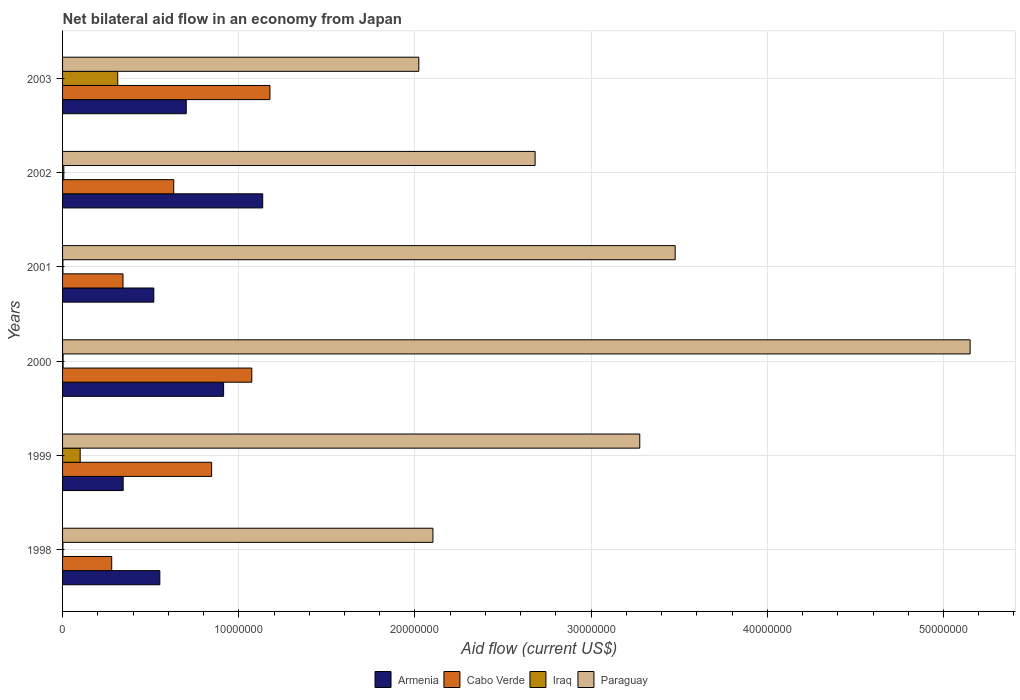How many groups of bars are there?
Offer a very short reply. 6. Are the number of bars on each tick of the Y-axis equal?
Keep it short and to the point. Yes. How many bars are there on the 5th tick from the bottom?
Provide a short and direct response. 4. What is the label of the 6th group of bars from the top?
Your answer should be compact. 1998. What is the net bilateral aid flow in Cabo Verde in 2001?
Your response must be concise. 3.43e+06. Across all years, what is the maximum net bilateral aid flow in Iraq?
Your answer should be compact. 3.13e+06. Across all years, what is the minimum net bilateral aid flow in Armenia?
Give a very brief answer. 3.44e+06. In which year was the net bilateral aid flow in Paraguay maximum?
Offer a very short reply. 2000. In which year was the net bilateral aid flow in Armenia minimum?
Your response must be concise. 1999. What is the total net bilateral aid flow in Paraguay in the graph?
Your answer should be very brief. 1.87e+08. What is the difference between the net bilateral aid flow in Armenia in 1999 and that in 2000?
Ensure brevity in your answer.  -5.70e+06. What is the difference between the net bilateral aid flow in Armenia in 2000 and the net bilateral aid flow in Cabo Verde in 2001?
Ensure brevity in your answer.  5.71e+06. What is the average net bilateral aid flow in Armenia per year?
Keep it short and to the point. 6.94e+06. In the year 2002, what is the difference between the net bilateral aid flow in Paraguay and net bilateral aid flow in Cabo Verde?
Your response must be concise. 2.05e+07. What is the ratio of the net bilateral aid flow in Armenia in 1998 to that in 2001?
Provide a succinct answer. 1.07. Is the net bilateral aid flow in Paraguay in 1998 less than that in 2001?
Keep it short and to the point. Yes. Is the difference between the net bilateral aid flow in Paraguay in 2001 and 2002 greater than the difference between the net bilateral aid flow in Cabo Verde in 2001 and 2002?
Your response must be concise. Yes. What is the difference between the highest and the second highest net bilateral aid flow in Cabo Verde?
Offer a terse response. 1.03e+06. What is the difference between the highest and the lowest net bilateral aid flow in Armenia?
Keep it short and to the point. 7.92e+06. In how many years, is the net bilateral aid flow in Cabo Verde greater than the average net bilateral aid flow in Cabo Verde taken over all years?
Provide a short and direct response. 3. What does the 3rd bar from the top in 1999 represents?
Your answer should be very brief. Cabo Verde. What does the 2nd bar from the bottom in 2000 represents?
Your response must be concise. Cabo Verde. How many years are there in the graph?
Make the answer very short. 6. What is the difference between two consecutive major ticks on the X-axis?
Your answer should be very brief. 1.00e+07. Does the graph contain any zero values?
Your answer should be compact. No. Where does the legend appear in the graph?
Provide a succinct answer. Bottom center. What is the title of the graph?
Provide a short and direct response. Net bilateral aid flow in an economy from Japan. Does "Turkmenistan" appear as one of the legend labels in the graph?
Offer a very short reply. No. What is the label or title of the X-axis?
Provide a short and direct response. Aid flow (current US$). What is the label or title of the Y-axis?
Your answer should be very brief. Years. What is the Aid flow (current US$) of Armenia in 1998?
Ensure brevity in your answer.  5.52e+06. What is the Aid flow (current US$) of Cabo Verde in 1998?
Keep it short and to the point. 2.79e+06. What is the Aid flow (current US$) of Iraq in 1998?
Your response must be concise. 2.00e+04. What is the Aid flow (current US$) in Paraguay in 1998?
Your response must be concise. 2.10e+07. What is the Aid flow (current US$) of Armenia in 1999?
Ensure brevity in your answer.  3.44e+06. What is the Aid flow (current US$) in Cabo Verde in 1999?
Make the answer very short. 8.46e+06. What is the Aid flow (current US$) in Paraguay in 1999?
Provide a short and direct response. 3.28e+07. What is the Aid flow (current US$) of Armenia in 2000?
Give a very brief answer. 9.14e+06. What is the Aid flow (current US$) in Cabo Verde in 2000?
Your answer should be very brief. 1.07e+07. What is the Aid flow (current US$) in Paraguay in 2000?
Provide a short and direct response. 5.15e+07. What is the Aid flow (current US$) in Armenia in 2001?
Provide a succinct answer. 5.18e+06. What is the Aid flow (current US$) of Cabo Verde in 2001?
Make the answer very short. 3.43e+06. What is the Aid flow (current US$) in Iraq in 2001?
Provide a short and direct response. 2.00e+04. What is the Aid flow (current US$) of Paraguay in 2001?
Make the answer very short. 3.48e+07. What is the Aid flow (current US$) of Armenia in 2002?
Keep it short and to the point. 1.14e+07. What is the Aid flow (current US$) in Cabo Verde in 2002?
Provide a succinct answer. 6.31e+06. What is the Aid flow (current US$) of Paraguay in 2002?
Provide a succinct answer. 2.68e+07. What is the Aid flow (current US$) in Armenia in 2003?
Your response must be concise. 7.02e+06. What is the Aid flow (current US$) of Cabo Verde in 2003?
Offer a very short reply. 1.18e+07. What is the Aid flow (current US$) in Iraq in 2003?
Make the answer very short. 3.13e+06. What is the Aid flow (current US$) in Paraguay in 2003?
Provide a succinct answer. 2.02e+07. Across all years, what is the maximum Aid flow (current US$) in Armenia?
Ensure brevity in your answer.  1.14e+07. Across all years, what is the maximum Aid flow (current US$) in Cabo Verde?
Your response must be concise. 1.18e+07. Across all years, what is the maximum Aid flow (current US$) of Iraq?
Provide a succinct answer. 3.13e+06. Across all years, what is the maximum Aid flow (current US$) of Paraguay?
Ensure brevity in your answer.  5.15e+07. Across all years, what is the minimum Aid flow (current US$) in Armenia?
Provide a succinct answer. 3.44e+06. Across all years, what is the minimum Aid flow (current US$) of Cabo Verde?
Your response must be concise. 2.79e+06. Across all years, what is the minimum Aid flow (current US$) of Iraq?
Keep it short and to the point. 2.00e+04. Across all years, what is the minimum Aid flow (current US$) of Paraguay?
Ensure brevity in your answer.  2.02e+07. What is the total Aid flow (current US$) of Armenia in the graph?
Offer a very short reply. 4.17e+07. What is the total Aid flow (current US$) in Cabo Verde in the graph?
Your answer should be compact. 4.35e+07. What is the total Aid flow (current US$) of Iraq in the graph?
Offer a terse response. 4.27e+06. What is the total Aid flow (current US$) in Paraguay in the graph?
Give a very brief answer. 1.87e+08. What is the difference between the Aid flow (current US$) of Armenia in 1998 and that in 1999?
Offer a very short reply. 2.08e+06. What is the difference between the Aid flow (current US$) of Cabo Verde in 1998 and that in 1999?
Your response must be concise. -5.67e+06. What is the difference between the Aid flow (current US$) in Iraq in 1998 and that in 1999?
Provide a short and direct response. -9.80e+05. What is the difference between the Aid flow (current US$) in Paraguay in 1998 and that in 1999?
Keep it short and to the point. -1.17e+07. What is the difference between the Aid flow (current US$) in Armenia in 1998 and that in 2000?
Ensure brevity in your answer.  -3.62e+06. What is the difference between the Aid flow (current US$) in Cabo Verde in 1998 and that in 2000?
Provide a succinct answer. -7.95e+06. What is the difference between the Aid flow (current US$) of Paraguay in 1998 and that in 2000?
Offer a very short reply. -3.05e+07. What is the difference between the Aid flow (current US$) of Cabo Verde in 1998 and that in 2001?
Make the answer very short. -6.40e+05. What is the difference between the Aid flow (current US$) in Iraq in 1998 and that in 2001?
Offer a very short reply. 0. What is the difference between the Aid flow (current US$) in Paraguay in 1998 and that in 2001?
Provide a short and direct response. -1.38e+07. What is the difference between the Aid flow (current US$) of Armenia in 1998 and that in 2002?
Make the answer very short. -5.84e+06. What is the difference between the Aid flow (current US$) in Cabo Verde in 1998 and that in 2002?
Provide a succinct answer. -3.52e+06. What is the difference between the Aid flow (current US$) of Paraguay in 1998 and that in 2002?
Your response must be concise. -5.80e+06. What is the difference between the Aid flow (current US$) in Armenia in 1998 and that in 2003?
Your answer should be compact. -1.50e+06. What is the difference between the Aid flow (current US$) of Cabo Verde in 1998 and that in 2003?
Offer a very short reply. -8.98e+06. What is the difference between the Aid flow (current US$) of Iraq in 1998 and that in 2003?
Offer a very short reply. -3.11e+06. What is the difference between the Aid flow (current US$) in Armenia in 1999 and that in 2000?
Your answer should be compact. -5.70e+06. What is the difference between the Aid flow (current US$) in Cabo Verde in 1999 and that in 2000?
Provide a succinct answer. -2.28e+06. What is the difference between the Aid flow (current US$) of Iraq in 1999 and that in 2000?
Provide a succinct answer. 9.70e+05. What is the difference between the Aid flow (current US$) in Paraguay in 1999 and that in 2000?
Your answer should be very brief. -1.88e+07. What is the difference between the Aid flow (current US$) in Armenia in 1999 and that in 2001?
Ensure brevity in your answer.  -1.74e+06. What is the difference between the Aid flow (current US$) of Cabo Verde in 1999 and that in 2001?
Make the answer very short. 5.03e+06. What is the difference between the Aid flow (current US$) in Iraq in 1999 and that in 2001?
Make the answer very short. 9.80e+05. What is the difference between the Aid flow (current US$) of Paraguay in 1999 and that in 2001?
Your answer should be very brief. -2.01e+06. What is the difference between the Aid flow (current US$) in Armenia in 1999 and that in 2002?
Your answer should be compact. -7.92e+06. What is the difference between the Aid flow (current US$) in Cabo Verde in 1999 and that in 2002?
Provide a succinct answer. 2.15e+06. What is the difference between the Aid flow (current US$) of Iraq in 1999 and that in 2002?
Ensure brevity in your answer.  9.30e+05. What is the difference between the Aid flow (current US$) in Paraguay in 1999 and that in 2002?
Your answer should be compact. 5.94e+06. What is the difference between the Aid flow (current US$) in Armenia in 1999 and that in 2003?
Your response must be concise. -3.58e+06. What is the difference between the Aid flow (current US$) of Cabo Verde in 1999 and that in 2003?
Keep it short and to the point. -3.31e+06. What is the difference between the Aid flow (current US$) of Iraq in 1999 and that in 2003?
Ensure brevity in your answer.  -2.13e+06. What is the difference between the Aid flow (current US$) in Paraguay in 1999 and that in 2003?
Keep it short and to the point. 1.25e+07. What is the difference between the Aid flow (current US$) in Armenia in 2000 and that in 2001?
Provide a succinct answer. 3.96e+06. What is the difference between the Aid flow (current US$) of Cabo Verde in 2000 and that in 2001?
Your response must be concise. 7.31e+06. What is the difference between the Aid flow (current US$) in Iraq in 2000 and that in 2001?
Your response must be concise. 10000. What is the difference between the Aid flow (current US$) in Paraguay in 2000 and that in 2001?
Your answer should be very brief. 1.67e+07. What is the difference between the Aid flow (current US$) of Armenia in 2000 and that in 2002?
Offer a terse response. -2.22e+06. What is the difference between the Aid flow (current US$) of Cabo Verde in 2000 and that in 2002?
Provide a short and direct response. 4.43e+06. What is the difference between the Aid flow (current US$) in Paraguay in 2000 and that in 2002?
Provide a succinct answer. 2.47e+07. What is the difference between the Aid flow (current US$) of Armenia in 2000 and that in 2003?
Your answer should be very brief. 2.12e+06. What is the difference between the Aid flow (current US$) in Cabo Verde in 2000 and that in 2003?
Your answer should be compact. -1.03e+06. What is the difference between the Aid flow (current US$) of Iraq in 2000 and that in 2003?
Offer a terse response. -3.10e+06. What is the difference between the Aid flow (current US$) in Paraguay in 2000 and that in 2003?
Provide a short and direct response. 3.13e+07. What is the difference between the Aid flow (current US$) in Armenia in 2001 and that in 2002?
Provide a short and direct response. -6.18e+06. What is the difference between the Aid flow (current US$) of Cabo Verde in 2001 and that in 2002?
Keep it short and to the point. -2.88e+06. What is the difference between the Aid flow (current US$) of Paraguay in 2001 and that in 2002?
Your answer should be compact. 7.95e+06. What is the difference between the Aid flow (current US$) of Armenia in 2001 and that in 2003?
Provide a succinct answer. -1.84e+06. What is the difference between the Aid flow (current US$) of Cabo Verde in 2001 and that in 2003?
Your answer should be compact. -8.34e+06. What is the difference between the Aid flow (current US$) in Iraq in 2001 and that in 2003?
Your answer should be compact. -3.11e+06. What is the difference between the Aid flow (current US$) in Paraguay in 2001 and that in 2003?
Keep it short and to the point. 1.46e+07. What is the difference between the Aid flow (current US$) in Armenia in 2002 and that in 2003?
Offer a terse response. 4.34e+06. What is the difference between the Aid flow (current US$) of Cabo Verde in 2002 and that in 2003?
Provide a short and direct response. -5.46e+06. What is the difference between the Aid flow (current US$) of Iraq in 2002 and that in 2003?
Your response must be concise. -3.06e+06. What is the difference between the Aid flow (current US$) of Paraguay in 2002 and that in 2003?
Your answer should be compact. 6.60e+06. What is the difference between the Aid flow (current US$) of Armenia in 1998 and the Aid flow (current US$) of Cabo Verde in 1999?
Your answer should be compact. -2.94e+06. What is the difference between the Aid flow (current US$) in Armenia in 1998 and the Aid flow (current US$) in Iraq in 1999?
Offer a terse response. 4.52e+06. What is the difference between the Aid flow (current US$) in Armenia in 1998 and the Aid flow (current US$) in Paraguay in 1999?
Your response must be concise. -2.72e+07. What is the difference between the Aid flow (current US$) of Cabo Verde in 1998 and the Aid flow (current US$) of Iraq in 1999?
Your response must be concise. 1.79e+06. What is the difference between the Aid flow (current US$) of Cabo Verde in 1998 and the Aid flow (current US$) of Paraguay in 1999?
Your answer should be compact. -3.00e+07. What is the difference between the Aid flow (current US$) in Iraq in 1998 and the Aid flow (current US$) in Paraguay in 1999?
Keep it short and to the point. -3.27e+07. What is the difference between the Aid flow (current US$) in Armenia in 1998 and the Aid flow (current US$) in Cabo Verde in 2000?
Your answer should be compact. -5.22e+06. What is the difference between the Aid flow (current US$) in Armenia in 1998 and the Aid flow (current US$) in Iraq in 2000?
Ensure brevity in your answer.  5.49e+06. What is the difference between the Aid flow (current US$) of Armenia in 1998 and the Aid flow (current US$) of Paraguay in 2000?
Your response must be concise. -4.60e+07. What is the difference between the Aid flow (current US$) of Cabo Verde in 1998 and the Aid flow (current US$) of Iraq in 2000?
Provide a succinct answer. 2.76e+06. What is the difference between the Aid flow (current US$) of Cabo Verde in 1998 and the Aid flow (current US$) of Paraguay in 2000?
Give a very brief answer. -4.87e+07. What is the difference between the Aid flow (current US$) of Iraq in 1998 and the Aid flow (current US$) of Paraguay in 2000?
Offer a very short reply. -5.15e+07. What is the difference between the Aid flow (current US$) in Armenia in 1998 and the Aid flow (current US$) in Cabo Verde in 2001?
Provide a short and direct response. 2.09e+06. What is the difference between the Aid flow (current US$) in Armenia in 1998 and the Aid flow (current US$) in Iraq in 2001?
Your response must be concise. 5.50e+06. What is the difference between the Aid flow (current US$) of Armenia in 1998 and the Aid flow (current US$) of Paraguay in 2001?
Keep it short and to the point. -2.92e+07. What is the difference between the Aid flow (current US$) in Cabo Verde in 1998 and the Aid flow (current US$) in Iraq in 2001?
Keep it short and to the point. 2.77e+06. What is the difference between the Aid flow (current US$) of Cabo Verde in 1998 and the Aid flow (current US$) of Paraguay in 2001?
Provide a short and direct response. -3.20e+07. What is the difference between the Aid flow (current US$) in Iraq in 1998 and the Aid flow (current US$) in Paraguay in 2001?
Your response must be concise. -3.48e+07. What is the difference between the Aid flow (current US$) of Armenia in 1998 and the Aid flow (current US$) of Cabo Verde in 2002?
Provide a succinct answer. -7.90e+05. What is the difference between the Aid flow (current US$) in Armenia in 1998 and the Aid flow (current US$) in Iraq in 2002?
Offer a terse response. 5.45e+06. What is the difference between the Aid flow (current US$) in Armenia in 1998 and the Aid flow (current US$) in Paraguay in 2002?
Offer a terse response. -2.13e+07. What is the difference between the Aid flow (current US$) of Cabo Verde in 1998 and the Aid flow (current US$) of Iraq in 2002?
Your answer should be very brief. 2.72e+06. What is the difference between the Aid flow (current US$) of Cabo Verde in 1998 and the Aid flow (current US$) of Paraguay in 2002?
Your response must be concise. -2.40e+07. What is the difference between the Aid flow (current US$) of Iraq in 1998 and the Aid flow (current US$) of Paraguay in 2002?
Your response must be concise. -2.68e+07. What is the difference between the Aid flow (current US$) in Armenia in 1998 and the Aid flow (current US$) in Cabo Verde in 2003?
Offer a very short reply. -6.25e+06. What is the difference between the Aid flow (current US$) of Armenia in 1998 and the Aid flow (current US$) of Iraq in 2003?
Provide a short and direct response. 2.39e+06. What is the difference between the Aid flow (current US$) of Armenia in 1998 and the Aid flow (current US$) of Paraguay in 2003?
Provide a short and direct response. -1.47e+07. What is the difference between the Aid flow (current US$) of Cabo Verde in 1998 and the Aid flow (current US$) of Paraguay in 2003?
Ensure brevity in your answer.  -1.74e+07. What is the difference between the Aid flow (current US$) of Iraq in 1998 and the Aid flow (current US$) of Paraguay in 2003?
Ensure brevity in your answer.  -2.02e+07. What is the difference between the Aid flow (current US$) in Armenia in 1999 and the Aid flow (current US$) in Cabo Verde in 2000?
Your response must be concise. -7.30e+06. What is the difference between the Aid flow (current US$) of Armenia in 1999 and the Aid flow (current US$) of Iraq in 2000?
Your answer should be compact. 3.41e+06. What is the difference between the Aid flow (current US$) of Armenia in 1999 and the Aid flow (current US$) of Paraguay in 2000?
Your answer should be compact. -4.81e+07. What is the difference between the Aid flow (current US$) of Cabo Verde in 1999 and the Aid flow (current US$) of Iraq in 2000?
Your answer should be compact. 8.43e+06. What is the difference between the Aid flow (current US$) in Cabo Verde in 1999 and the Aid flow (current US$) in Paraguay in 2000?
Offer a terse response. -4.30e+07. What is the difference between the Aid flow (current US$) of Iraq in 1999 and the Aid flow (current US$) of Paraguay in 2000?
Provide a short and direct response. -5.05e+07. What is the difference between the Aid flow (current US$) of Armenia in 1999 and the Aid flow (current US$) of Iraq in 2001?
Ensure brevity in your answer.  3.42e+06. What is the difference between the Aid flow (current US$) of Armenia in 1999 and the Aid flow (current US$) of Paraguay in 2001?
Give a very brief answer. -3.13e+07. What is the difference between the Aid flow (current US$) of Cabo Verde in 1999 and the Aid flow (current US$) of Iraq in 2001?
Provide a succinct answer. 8.44e+06. What is the difference between the Aid flow (current US$) of Cabo Verde in 1999 and the Aid flow (current US$) of Paraguay in 2001?
Your response must be concise. -2.63e+07. What is the difference between the Aid flow (current US$) in Iraq in 1999 and the Aid flow (current US$) in Paraguay in 2001?
Your answer should be very brief. -3.38e+07. What is the difference between the Aid flow (current US$) in Armenia in 1999 and the Aid flow (current US$) in Cabo Verde in 2002?
Offer a very short reply. -2.87e+06. What is the difference between the Aid flow (current US$) in Armenia in 1999 and the Aid flow (current US$) in Iraq in 2002?
Make the answer very short. 3.37e+06. What is the difference between the Aid flow (current US$) in Armenia in 1999 and the Aid flow (current US$) in Paraguay in 2002?
Offer a very short reply. -2.34e+07. What is the difference between the Aid flow (current US$) of Cabo Verde in 1999 and the Aid flow (current US$) of Iraq in 2002?
Make the answer very short. 8.39e+06. What is the difference between the Aid flow (current US$) of Cabo Verde in 1999 and the Aid flow (current US$) of Paraguay in 2002?
Ensure brevity in your answer.  -1.84e+07. What is the difference between the Aid flow (current US$) in Iraq in 1999 and the Aid flow (current US$) in Paraguay in 2002?
Offer a very short reply. -2.58e+07. What is the difference between the Aid flow (current US$) of Armenia in 1999 and the Aid flow (current US$) of Cabo Verde in 2003?
Provide a short and direct response. -8.33e+06. What is the difference between the Aid flow (current US$) of Armenia in 1999 and the Aid flow (current US$) of Paraguay in 2003?
Ensure brevity in your answer.  -1.68e+07. What is the difference between the Aid flow (current US$) in Cabo Verde in 1999 and the Aid flow (current US$) in Iraq in 2003?
Make the answer very short. 5.33e+06. What is the difference between the Aid flow (current US$) in Cabo Verde in 1999 and the Aid flow (current US$) in Paraguay in 2003?
Your answer should be very brief. -1.18e+07. What is the difference between the Aid flow (current US$) in Iraq in 1999 and the Aid flow (current US$) in Paraguay in 2003?
Your answer should be compact. -1.92e+07. What is the difference between the Aid flow (current US$) of Armenia in 2000 and the Aid flow (current US$) of Cabo Verde in 2001?
Make the answer very short. 5.71e+06. What is the difference between the Aid flow (current US$) in Armenia in 2000 and the Aid flow (current US$) in Iraq in 2001?
Keep it short and to the point. 9.12e+06. What is the difference between the Aid flow (current US$) of Armenia in 2000 and the Aid flow (current US$) of Paraguay in 2001?
Make the answer very short. -2.56e+07. What is the difference between the Aid flow (current US$) in Cabo Verde in 2000 and the Aid flow (current US$) in Iraq in 2001?
Provide a succinct answer. 1.07e+07. What is the difference between the Aid flow (current US$) of Cabo Verde in 2000 and the Aid flow (current US$) of Paraguay in 2001?
Ensure brevity in your answer.  -2.40e+07. What is the difference between the Aid flow (current US$) of Iraq in 2000 and the Aid flow (current US$) of Paraguay in 2001?
Your response must be concise. -3.47e+07. What is the difference between the Aid flow (current US$) in Armenia in 2000 and the Aid flow (current US$) in Cabo Verde in 2002?
Your response must be concise. 2.83e+06. What is the difference between the Aid flow (current US$) of Armenia in 2000 and the Aid flow (current US$) of Iraq in 2002?
Your answer should be compact. 9.07e+06. What is the difference between the Aid flow (current US$) in Armenia in 2000 and the Aid flow (current US$) in Paraguay in 2002?
Provide a short and direct response. -1.77e+07. What is the difference between the Aid flow (current US$) of Cabo Verde in 2000 and the Aid flow (current US$) of Iraq in 2002?
Offer a very short reply. 1.07e+07. What is the difference between the Aid flow (current US$) of Cabo Verde in 2000 and the Aid flow (current US$) of Paraguay in 2002?
Offer a terse response. -1.61e+07. What is the difference between the Aid flow (current US$) of Iraq in 2000 and the Aid flow (current US$) of Paraguay in 2002?
Your answer should be very brief. -2.68e+07. What is the difference between the Aid flow (current US$) in Armenia in 2000 and the Aid flow (current US$) in Cabo Verde in 2003?
Keep it short and to the point. -2.63e+06. What is the difference between the Aid flow (current US$) of Armenia in 2000 and the Aid flow (current US$) of Iraq in 2003?
Offer a terse response. 6.01e+06. What is the difference between the Aid flow (current US$) in Armenia in 2000 and the Aid flow (current US$) in Paraguay in 2003?
Ensure brevity in your answer.  -1.11e+07. What is the difference between the Aid flow (current US$) in Cabo Verde in 2000 and the Aid flow (current US$) in Iraq in 2003?
Provide a succinct answer. 7.61e+06. What is the difference between the Aid flow (current US$) of Cabo Verde in 2000 and the Aid flow (current US$) of Paraguay in 2003?
Your answer should be very brief. -9.48e+06. What is the difference between the Aid flow (current US$) of Iraq in 2000 and the Aid flow (current US$) of Paraguay in 2003?
Make the answer very short. -2.02e+07. What is the difference between the Aid flow (current US$) in Armenia in 2001 and the Aid flow (current US$) in Cabo Verde in 2002?
Offer a very short reply. -1.13e+06. What is the difference between the Aid flow (current US$) in Armenia in 2001 and the Aid flow (current US$) in Iraq in 2002?
Your answer should be very brief. 5.11e+06. What is the difference between the Aid flow (current US$) in Armenia in 2001 and the Aid flow (current US$) in Paraguay in 2002?
Keep it short and to the point. -2.16e+07. What is the difference between the Aid flow (current US$) in Cabo Verde in 2001 and the Aid flow (current US$) in Iraq in 2002?
Your answer should be very brief. 3.36e+06. What is the difference between the Aid flow (current US$) in Cabo Verde in 2001 and the Aid flow (current US$) in Paraguay in 2002?
Your answer should be very brief. -2.34e+07. What is the difference between the Aid flow (current US$) in Iraq in 2001 and the Aid flow (current US$) in Paraguay in 2002?
Ensure brevity in your answer.  -2.68e+07. What is the difference between the Aid flow (current US$) in Armenia in 2001 and the Aid flow (current US$) in Cabo Verde in 2003?
Your answer should be compact. -6.59e+06. What is the difference between the Aid flow (current US$) in Armenia in 2001 and the Aid flow (current US$) in Iraq in 2003?
Offer a very short reply. 2.05e+06. What is the difference between the Aid flow (current US$) of Armenia in 2001 and the Aid flow (current US$) of Paraguay in 2003?
Offer a very short reply. -1.50e+07. What is the difference between the Aid flow (current US$) of Cabo Verde in 2001 and the Aid flow (current US$) of Iraq in 2003?
Offer a very short reply. 3.00e+05. What is the difference between the Aid flow (current US$) in Cabo Verde in 2001 and the Aid flow (current US$) in Paraguay in 2003?
Give a very brief answer. -1.68e+07. What is the difference between the Aid flow (current US$) in Iraq in 2001 and the Aid flow (current US$) in Paraguay in 2003?
Your answer should be very brief. -2.02e+07. What is the difference between the Aid flow (current US$) in Armenia in 2002 and the Aid flow (current US$) in Cabo Verde in 2003?
Keep it short and to the point. -4.10e+05. What is the difference between the Aid flow (current US$) in Armenia in 2002 and the Aid flow (current US$) in Iraq in 2003?
Your answer should be compact. 8.23e+06. What is the difference between the Aid flow (current US$) in Armenia in 2002 and the Aid flow (current US$) in Paraguay in 2003?
Offer a terse response. -8.86e+06. What is the difference between the Aid flow (current US$) in Cabo Verde in 2002 and the Aid flow (current US$) in Iraq in 2003?
Your response must be concise. 3.18e+06. What is the difference between the Aid flow (current US$) of Cabo Verde in 2002 and the Aid flow (current US$) of Paraguay in 2003?
Provide a short and direct response. -1.39e+07. What is the difference between the Aid flow (current US$) in Iraq in 2002 and the Aid flow (current US$) in Paraguay in 2003?
Make the answer very short. -2.02e+07. What is the average Aid flow (current US$) in Armenia per year?
Give a very brief answer. 6.94e+06. What is the average Aid flow (current US$) of Cabo Verde per year?
Your answer should be compact. 7.25e+06. What is the average Aid flow (current US$) in Iraq per year?
Your response must be concise. 7.12e+05. What is the average Aid flow (current US$) of Paraguay per year?
Offer a terse response. 3.12e+07. In the year 1998, what is the difference between the Aid flow (current US$) of Armenia and Aid flow (current US$) of Cabo Verde?
Your response must be concise. 2.73e+06. In the year 1998, what is the difference between the Aid flow (current US$) of Armenia and Aid flow (current US$) of Iraq?
Your response must be concise. 5.50e+06. In the year 1998, what is the difference between the Aid flow (current US$) of Armenia and Aid flow (current US$) of Paraguay?
Provide a short and direct response. -1.55e+07. In the year 1998, what is the difference between the Aid flow (current US$) of Cabo Verde and Aid flow (current US$) of Iraq?
Make the answer very short. 2.77e+06. In the year 1998, what is the difference between the Aid flow (current US$) of Cabo Verde and Aid flow (current US$) of Paraguay?
Provide a short and direct response. -1.82e+07. In the year 1998, what is the difference between the Aid flow (current US$) in Iraq and Aid flow (current US$) in Paraguay?
Make the answer very short. -2.10e+07. In the year 1999, what is the difference between the Aid flow (current US$) of Armenia and Aid flow (current US$) of Cabo Verde?
Provide a short and direct response. -5.02e+06. In the year 1999, what is the difference between the Aid flow (current US$) of Armenia and Aid flow (current US$) of Iraq?
Give a very brief answer. 2.44e+06. In the year 1999, what is the difference between the Aid flow (current US$) in Armenia and Aid flow (current US$) in Paraguay?
Your answer should be very brief. -2.93e+07. In the year 1999, what is the difference between the Aid flow (current US$) of Cabo Verde and Aid flow (current US$) of Iraq?
Your answer should be very brief. 7.46e+06. In the year 1999, what is the difference between the Aid flow (current US$) in Cabo Verde and Aid flow (current US$) in Paraguay?
Provide a short and direct response. -2.43e+07. In the year 1999, what is the difference between the Aid flow (current US$) in Iraq and Aid flow (current US$) in Paraguay?
Provide a succinct answer. -3.18e+07. In the year 2000, what is the difference between the Aid flow (current US$) of Armenia and Aid flow (current US$) of Cabo Verde?
Your answer should be very brief. -1.60e+06. In the year 2000, what is the difference between the Aid flow (current US$) of Armenia and Aid flow (current US$) of Iraq?
Provide a short and direct response. 9.11e+06. In the year 2000, what is the difference between the Aid flow (current US$) of Armenia and Aid flow (current US$) of Paraguay?
Make the answer very short. -4.24e+07. In the year 2000, what is the difference between the Aid flow (current US$) in Cabo Verde and Aid flow (current US$) in Iraq?
Your response must be concise. 1.07e+07. In the year 2000, what is the difference between the Aid flow (current US$) in Cabo Verde and Aid flow (current US$) in Paraguay?
Give a very brief answer. -4.08e+07. In the year 2000, what is the difference between the Aid flow (current US$) of Iraq and Aid flow (current US$) of Paraguay?
Ensure brevity in your answer.  -5.15e+07. In the year 2001, what is the difference between the Aid flow (current US$) in Armenia and Aid flow (current US$) in Cabo Verde?
Your answer should be compact. 1.75e+06. In the year 2001, what is the difference between the Aid flow (current US$) in Armenia and Aid flow (current US$) in Iraq?
Ensure brevity in your answer.  5.16e+06. In the year 2001, what is the difference between the Aid flow (current US$) in Armenia and Aid flow (current US$) in Paraguay?
Give a very brief answer. -2.96e+07. In the year 2001, what is the difference between the Aid flow (current US$) in Cabo Verde and Aid flow (current US$) in Iraq?
Your answer should be compact. 3.41e+06. In the year 2001, what is the difference between the Aid flow (current US$) in Cabo Verde and Aid flow (current US$) in Paraguay?
Offer a terse response. -3.13e+07. In the year 2001, what is the difference between the Aid flow (current US$) in Iraq and Aid flow (current US$) in Paraguay?
Offer a very short reply. -3.48e+07. In the year 2002, what is the difference between the Aid flow (current US$) of Armenia and Aid flow (current US$) of Cabo Verde?
Offer a terse response. 5.05e+06. In the year 2002, what is the difference between the Aid flow (current US$) of Armenia and Aid flow (current US$) of Iraq?
Provide a short and direct response. 1.13e+07. In the year 2002, what is the difference between the Aid flow (current US$) in Armenia and Aid flow (current US$) in Paraguay?
Ensure brevity in your answer.  -1.55e+07. In the year 2002, what is the difference between the Aid flow (current US$) in Cabo Verde and Aid flow (current US$) in Iraq?
Ensure brevity in your answer.  6.24e+06. In the year 2002, what is the difference between the Aid flow (current US$) in Cabo Verde and Aid flow (current US$) in Paraguay?
Keep it short and to the point. -2.05e+07. In the year 2002, what is the difference between the Aid flow (current US$) in Iraq and Aid flow (current US$) in Paraguay?
Give a very brief answer. -2.68e+07. In the year 2003, what is the difference between the Aid flow (current US$) in Armenia and Aid flow (current US$) in Cabo Verde?
Your response must be concise. -4.75e+06. In the year 2003, what is the difference between the Aid flow (current US$) of Armenia and Aid flow (current US$) of Iraq?
Your answer should be compact. 3.89e+06. In the year 2003, what is the difference between the Aid flow (current US$) in Armenia and Aid flow (current US$) in Paraguay?
Make the answer very short. -1.32e+07. In the year 2003, what is the difference between the Aid flow (current US$) of Cabo Verde and Aid flow (current US$) of Iraq?
Your response must be concise. 8.64e+06. In the year 2003, what is the difference between the Aid flow (current US$) of Cabo Verde and Aid flow (current US$) of Paraguay?
Ensure brevity in your answer.  -8.45e+06. In the year 2003, what is the difference between the Aid flow (current US$) in Iraq and Aid flow (current US$) in Paraguay?
Keep it short and to the point. -1.71e+07. What is the ratio of the Aid flow (current US$) of Armenia in 1998 to that in 1999?
Your response must be concise. 1.6. What is the ratio of the Aid flow (current US$) of Cabo Verde in 1998 to that in 1999?
Give a very brief answer. 0.33. What is the ratio of the Aid flow (current US$) of Paraguay in 1998 to that in 1999?
Your response must be concise. 0.64. What is the ratio of the Aid flow (current US$) of Armenia in 1998 to that in 2000?
Make the answer very short. 0.6. What is the ratio of the Aid flow (current US$) of Cabo Verde in 1998 to that in 2000?
Keep it short and to the point. 0.26. What is the ratio of the Aid flow (current US$) of Paraguay in 1998 to that in 2000?
Ensure brevity in your answer.  0.41. What is the ratio of the Aid flow (current US$) of Armenia in 1998 to that in 2001?
Offer a terse response. 1.07. What is the ratio of the Aid flow (current US$) of Cabo Verde in 1998 to that in 2001?
Your answer should be very brief. 0.81. What is the ratio of the Aid flow (current US$) of Iraq in 1998 to that in 2001?
Offer a very short reply. 1. What is the ratio of the Aid flow (current US$) in Paraguay in 1998 to that in 2001?
Give a very brief answer. 0.6. What is the ratio of the Aid flow (current US$) of Armenia in 1998 to that in 2002?
Provide a succinct answer. 0.49. What is the ratio of the Aid flow (current US$) in Cabo Verde in 1998 to that in 2002?
Give a very brief answer. 0.44. What is the ratio of the Aid flow (current US$) in Iraq in 1998 to that in 2002?
Offer a very short reply. 0.29. What is the ratio of the Aid flow (current US$) in Paraguay in 1998 to that in 2002?
Give a very brief answer. 0.78. What is the ratio of the Aid flow (current US$) of Armenia in 1998 to that in 2003?
Give a very brief answer. 0.79. What is the ratio of the Aid flow (current US$) of Cabo Verde in 1998 to that in 2003?
Provide a short and direct response. 0.24. What is the ratio of the Aid flow (current US$) of Iraq in 1998 to that in 2003?
Offer a very short reply. 0.01. What is the ratio of the Aid flow (current US$) in Paraguay in 1998 to that in 2003?
Provide a succinct answer. 1.04. What is the ratio of the Aid flow (current US$) of Armenia in 1999 to that in 2000?
Provide a short and direct response. 0.38. What is the ratio of the Aid flow (current US$) of Cabo Verde in 1999 to that in 2000?
Provide a short and direct response. 0.79. What is the ratio of the Aid flow (current US$) of Iraq in 1999 to that in 2000?
Give a very brief answer. 33.33. What is the ratio of the Aid flow (current US$) in Paraguay in 1999 to that in 2000?
Provide a short and direct response. 0.64. What is the ratio of the Aid flow (current US$) of Armenia in 1999 to that in 2001?
Provide a succinct answer. 0.66. What is the ratio of the Aid flow (current US$) in Cabo Verde in 1999 to that in 2001?
Your answer should be compact. 2.47. What is the ratio of the Aid flow (current US$) in Paraguay in 1999 to that in 2001?
Provide a succinct answer. 0.94. What is the ratio of the Aid flow (current US$) in Armenia in 1999 to that in 2002?
Offer a terse response. 0.3. What is the ratio of the Aid flow (current US$) of Cabo Verde in 1999 to that in 2002?
Your response must be concise. 1.34. What is the ratio of the Aid flow (current US$) of Iraq in 1999 to that in 2002?
Provide a succinct answer. 14.29. What is the ratio of the Aid flow (current US$) in Paraguay in 1999 to that in 2002?
Offer a terse response. 1.22. What is the ratio of the Aid flow (current US$) of Armenia in 1999 to that in 2003?
Provide a succinct answer. 0.49. What is the ratio of the Aid flow (current US$) in Cabo Verde in 1999 to that in 2003?
Provide a short and direct response. 0.72. What is the ratio of the Aid flow (current US$) in Iraq in 1999 to that in 2003?
Make the answer very short. 0.32. What is the ratio of the Aid flow (current US$) of Paraguay in 1999 to that in 2003?
Keep it short and to the point. 1.62. What is the ratio of the Aid flow (current US$) in Armenia in 2000 to that in 2001?
Your answer should be compact. 1.76. What is the ratio of the Aid flow (current US$) of Cabo Verde in 2000 to that in 2001?
Your answer should be very brief. 3.13. What is the ratio of the Aid flow (current US$) in Iraq in 2000 to that in 2001?
Ensure brevity in your answer.  1.5. What is the ratio of the Aid flow (current US$) of Paraguay in 2000 to that in 2001?
Your answer should be compact. 1.48. What is the ratio of the Aid flow (current US$) of Armenia in 2000 to that in 2002?
Make the answer very short. 0.8. What is the ratio of the Aid flow (current US$) of Cabo Verde in 2000 to that in 2002?
Provide a short and direct response. 1.7. What is the ratio of the Aid flow (current US$) in Iraq in 2000 to that in 2002?
Offer a terse response. 0.43. What is the ratio of the Aid flow (current US$) in Paraguay in 2000 to that in 2002?
Your response must be concise. 1.92. What is the ratio of the Aid flow (current US$) in Armenia in 2000 to that in 2003?
Give a very brief answer. 1.3. What is the ratio of the Aid flow (current US$) of Cabo Verde in 2000 to that in 2003?
Give a very brief answer. 0.91. What is the ratio of the Aid flow (current US$) of Iraq in 2000 to that in 2003?
Offer a terse response. 0.01. What is the ratio of the Aid flow (current US$) in Paraguay in 2000 to that in 2003?
Your answer should be compact. 2.55. What is the ratio of the Aid flow (current US$) of Armenia in 2001 to that in 2002?
Ensure brevity in your answer.  0.46. What is the ratio of the Aid flow (current US$) in Cabo Verde in 2001 to that in 2002?
Keep it short and to the point. 0.54. What is the ratio of the Aid flow (current US$) of Iraq in 2001 to that in 2002?
Provide a succinct answer. 0.29. What is the ratio of the Aid flow (current US$) of Paraguay in 2001 to that in 2002?
Provide a short and direct response. 1.3. What is the ratio of the Aid flow (current US$) of Armenia in 2001 to that in 2003?
Ensure brevity in your answer.  0.74. What is the ratio of the Aid flow (current US$) of Cabo Verde in 2001 to that in 2003?
Offer a terse response. 0.29. What is the ratio of the Aid flow (current US$) of Iraq in 2001 to that in 2003?
Your answer should be very brief. 0.01. What is the ratio of the Aid flow (current US$) of Paraguay in 2001 to that in 2003?
Your answer should be very brief. 1.72. What is the ratio of the Aid flow (current US$) in Armenia in 2002 to that in 2003?
Provide a short and direct response. 1.62. What is the ratio of the Aid flow (current US$) of Cabo Verde in 2002 to that in 2003?
Make the answer very short. 0.54. What is the ratio of the Aid flow (current US$) in Iraq in 2002 to that in 2003?
Provide a short and direct response. 0.02. What is the ratio of the Aid flow (current US$) in Paraguay in 2002 to that in 2003?
Provide a succinct answer. 1.33. What is the difference between the highest and the second highest Aid flow (current US$) in Armenia?
Ensure brevity in your answer.  2.22e+06. What is the difference between the highest and the second highest Aid flow (current US$) in Cabo Verde?
Offer a very short reply. 1.03e+06. What is the difference between the highest and the second highest Aid flow (current US$) in Iraq?
Keep it short and to the point. 2.13e+06. What is the difference between the highest and the second highest Aid flow (current US$) in Paraguay?
Offer a terse response. 1.67e+07. What is the difference between the highest and the lowest Aid flow (current US$) of Armenia?
Ensure brevity in your answer.  7.92e+06. What is the difference between the highest and the lowest Aid flow (current US$) in Cabo Verde?
Ensure brevity in your answer.  8.98e+06. What is the difference between the highest and the lowest Aid flow (current US$) of Iraq?
Ensure brevity in your answer.  3.11e+06. What is the difference between the highest and the lowest Aid flow (current US$) in Paraguay?
Your response must be concise. 3.13e+07. 